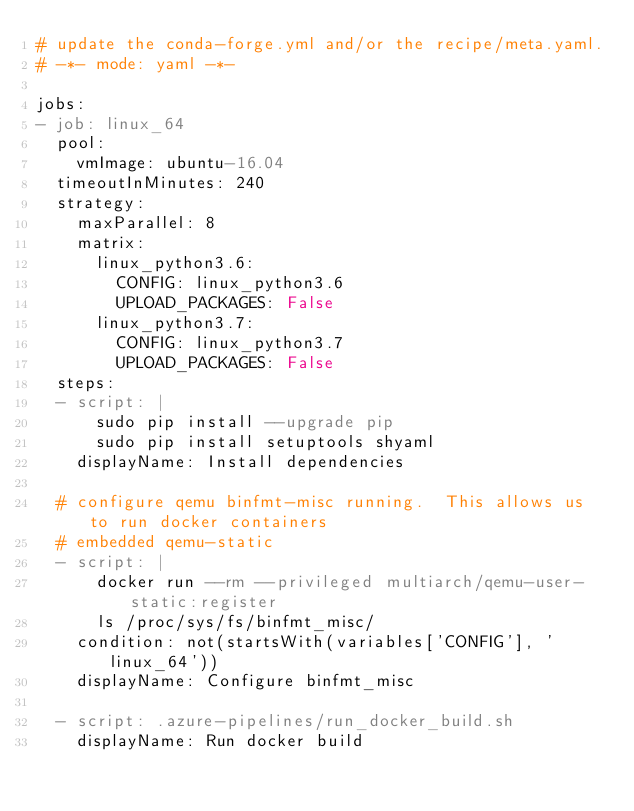<code> <loc_0><loc_0><loc_500><loc_500><_YAML_># update the conda-forge.yml and/or the recipe/meta.yaml.
# -*- mode: yaml -*-

jobs:
- job: linux_64
  pool:
    vmImage: ubuntu-16.04
  timeoutInMinutes: 240
  strategy:
    maxParallel: 8
    matrix:
      linux_python3.6:
        CONFIG: linux_python3.6
        UPLOAD_PACKAGES: False
      linux_python3.7:
        CONFIG: linux_python3.7
        UPLOAD_PACKAGES: False
  steps:
  - script: |
      sudo pip install --upgrade pip
      sudo pip install setuptools shyaml
    displayName: Install dependencies

  # configure qemu binfmt-misc running.  This allows us to run docker containers 
  # embedded qemu-static
  - script: |
      docker run --rm --privileged multiarch/qemu-user-static:register
      ls /proc/sys/fs/binfmt_misc/
    condition: not(startsWith(variables['CONFIG'], 'linux_64'))
    displayName: Configure binfmt_misc

  - script: .azure-pipelines/run_docker_build.sh
    displayName: Run docker build</code> 